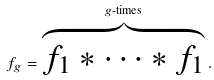<formula> <loc_0><loc_0><loc_500><loc_500>f _ { g } = \overset { g \text {-times} } { \overbrace { f _ { 1 } * \cdots * f _ { 1 } } } \, .</formula> 